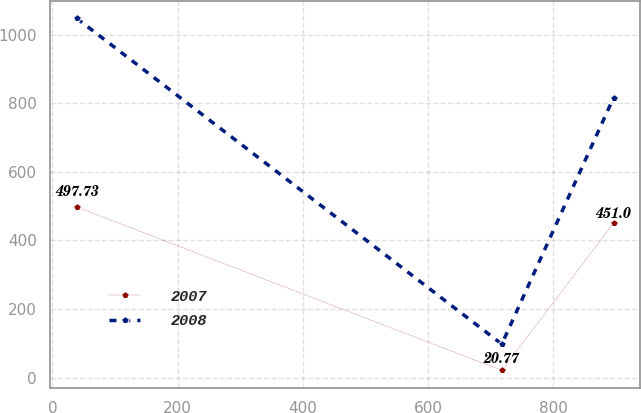Convert chart to OTSL. <chart><loc_0><loc_0><loc_500><loc_500><line_chart><ecel><fcel>2007<fcel>2008<nl><fcel>38.71<fcel>497.73<fcel>1048.43<nl><fcel>717.92<fcel>20.77<fcel>97.48<nl><fcel>896.38<fcel>451<fcel>816.18<nl></chart> 